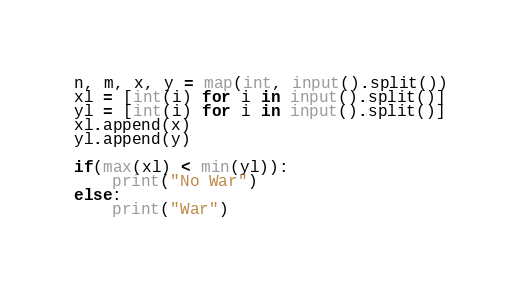<code> <loc_0><loc_0><loc_500><loc_500><_Python_>n, m, x, y = map(int, input().split())
xl = [int(i) for i in input().split()]
yl = [int(i) for i in input().split()]
xl.append(x)
yl.append(y)

if(max(xl) < min(yl)):
    print("No War")
else:
    print("War")
</code> 